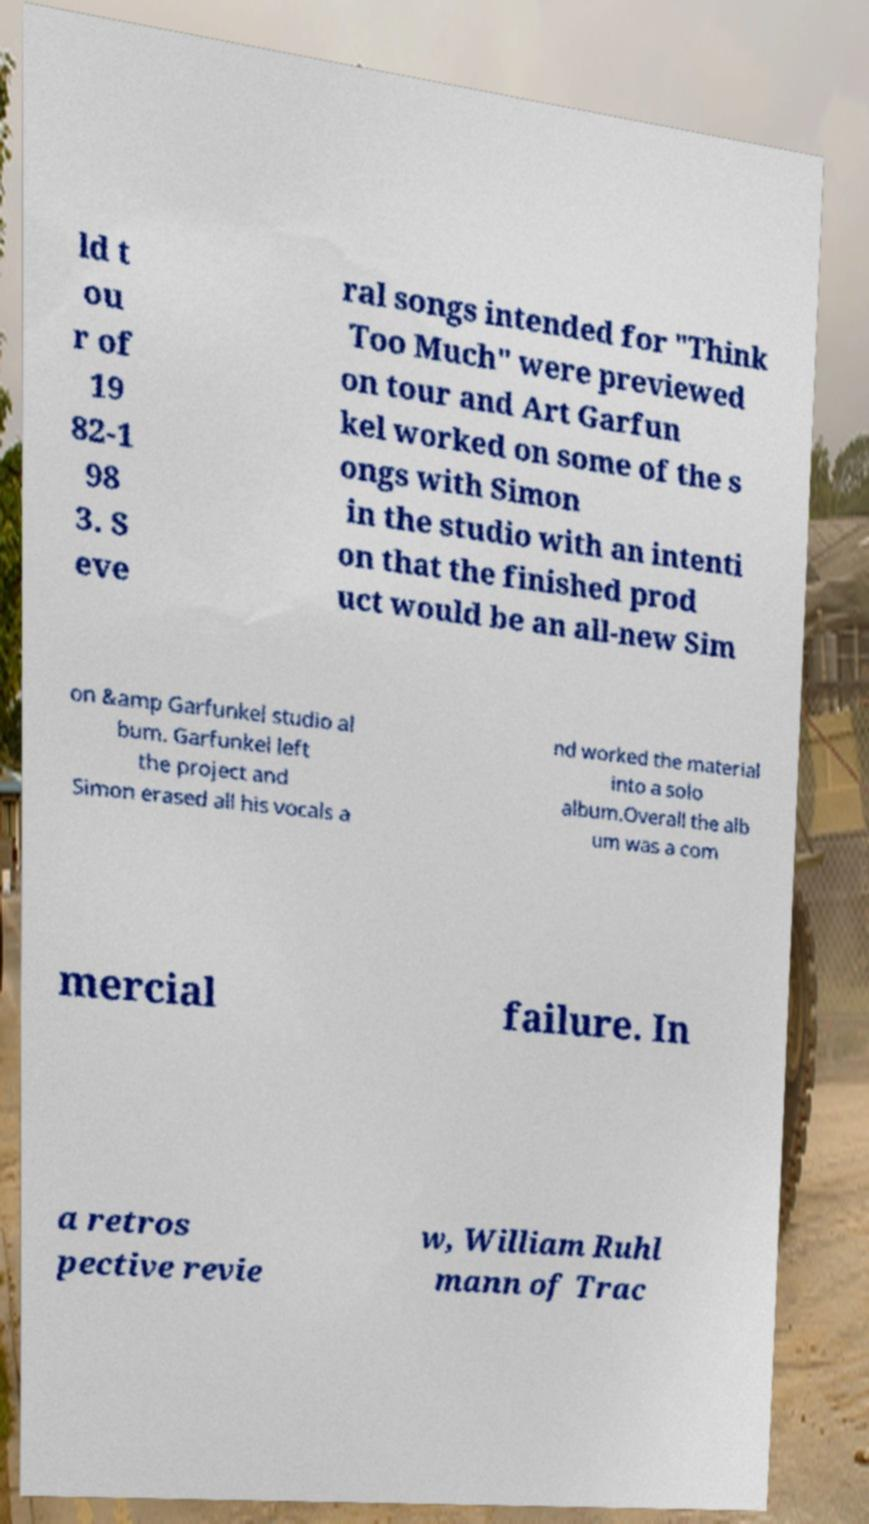Please identify and transcribe the text found in this image. ld t ou r of 19 82-1 98 3. S eve ral songs intended for "Think Too Much" were previewed on tour and Art Garfun kel worked on some of the s ongs with Simon in the studio with an intenti on that the finished prod uct would be an all-new Sim on &amp Garfunkel studio al bum. Garfunkel left the project and Simon erased all his vocals a nd worked the material into a solo album.Overall the alb um was a com mercial failure. In a retros pective revie w, William Ruhl mann of Trac 